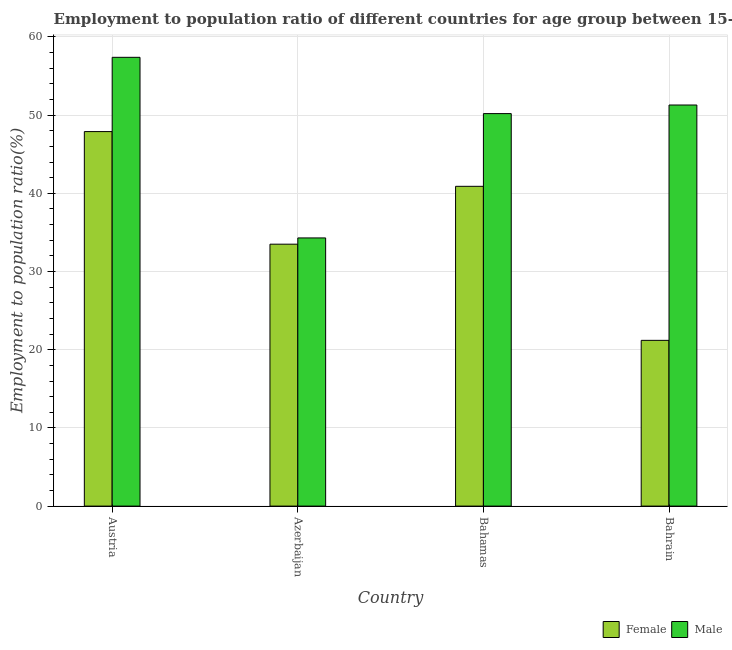How many different coloured bars are there?
Your answer should be compact. 2. How many groups of bars are there?
Offer a very short reply. 4. Are the number of bars per tick equal to the number of legend labels?
Give a very brief answer. Yes. How many bars are there on the 4th tick from the left?
Your response must be concise. 2. What is the label of the 4th group of bars from the left?
Keep it short and to the point. Bahrain. What is the employment to population ratio(female) in Azerbaijan?
Your answer should be compact. 33.5. Across all countries, what is the maximum employment to population ratio(male)?
Offer a terse response. 57.4. Across all countries, what is the minimum employment to population ratio(male)?
Provide a succinct answer. 34.3. In which country was the employment to population ratio(female) minimum?
Provide a short and direct response. Bahrain. What is the total employment to population ratio(male) in the graph?
Your response must be concise. 193.2. What is the difference between the employment to population ratio(male) in Bahamas and that in Bahrain?
Provide a short and direct response. -1.1. What is the difference between the employment to population ratio(male) in Bahamas and the employment to population ratio(female) in Austria?
Provide a succinct answer. 2.3. What is the average employment to population ratio(female) per country?
Ensure brevity in your answer.  35.88. What is the difference between the employment to population ratio(male) and employment to population ratio(female) in Bahamas?
Offer a terse response. 9.3. What is the ratio of the employment to population ratio(male) in Bahamas to that in Bahrain?
Keep it short and to the point. 0.98. Is the employment to population ratio(male) in Austria less than that in Bahrain?
Give a very brief answer. No. Is the difference between the employment to population ratio(female) in Azerbaijan and Bahamas greater than the difference between the employment to population ratio(male) in Azerbaijan and Bahamas?
Keep it short and to the point. Yes. What is the difference between the highest and the second highest employment to population ratio(male)?
Ensure brevity in your answer.  6.1. What is the difference between the highest and the lowest employment to population ratio(female)?
Your answer should be very brief. 26.7. In how many countries, is the employment to population ratio(female) greater than the average employment to population ratio(female) taken over all countries?
Ensure brevity in your answer.  2. Is the sum of the employment to population ratio(female) in Austria and Bahrain greater than the maximum employment to population ratio(male) across all countries?
Your answer should be very brief. Yes. What does the 2nd bar from the left in Bahrain represents?
Your answer should be very brief. Male. What does the 1st bar from the right in Austria represents?
Offer a terse response. Male. What is the difference between two consecutive major ticks on the Y-axis?
Offer a terse response. 10. Are the values on the major ticks of Y-axis written in scientific E-notation?
Offer a terse response. No. Does the graph contain any zero values?
Your response must be concise. No. Where does the legend appear in the graph?
Ensure brevity in your answer.  Bottom right. How many legend labels are there?
Offer a terse response. 2. How are the legend labels stacked?
Your answer should be very brief. Horizontal. What is the title of the graph?
Your answer should be compact. Employment to population ratio of different countries for age group between 15-24 years. What is the label or title of the X-axis?
Your answer should be compact. Country. What is the Employment to population ratio(%) of Female in Austria?
Your answer should be compact. 47.9. What is the Employment to population ratio(%) of Male in Austria?
Offer a terse response. 57.4. What is the Employment to population ratio(%) of Female in Azerbaijan?
Your response must be concise. 33.5. What is the Employment to population ratio(%) of Male in Azerbaijan?
Offer a very short reply. 34.3. What is the Employment to population ratio(%) in Female in Bahamas?
Provide a short and direct response. 40.9. What is the Employment to population ratio(%) of Male in Bahamas?
Ensure brevity in your answer.  50.2. What is the Employment to population ratio(%) in Female in Bahrain?
Offer a very short reply. 21.2. What is the Employment to population ratio(%) in Male in Bahrain?
Give a very brief answer. 51.3. Across all countries, what is the maximum Employment to population ratio(%) of Female?
Offer a terse response. 47.9. Across all countries, what is the maximum Employment to population ratio(%) in Male?
Provide a succinct answer. 57.4. Across all countries, what is the minimum Employment to population ratio(%) in Female?
Make the answer very short. 21.2. Across all countries, what is the minimum Employment to population ratio(%) of Male?
Offer a terse response. 34.3. What is the total Employment to population ratio(%) in Female in the graph?
Offer a terse response. 143.5. What is the total Employment to population ratio(%) of Male in the graph?
Your response must be concise. 193.2. What is the difference between the Employment to population ratio(%) in Female in Austria and that in Azerbaijan?
Your response must be concise. 14.4. What is the difference between the Employment to population ratio(%) in Male in Austria and that in Azerbaijan?
Your response must be concise. 23.1. What is the difference between the Employment to population ratio(%) of Female in Austria and that in Bahamas?
Your response must be concise. 7. What is the difference between the Employment to population ratio(%) in Male in Austria and that in Bahamas?
Your answer should be compact. 7.2. What is the difference between the Employment to population ratio(%) of Female in Austria and that in Bahrain?
Offer a terse response. 26.7. What is the difference between the Employment to population ratio(%) in Male in Austria and that in Bahrain?
Offer a terse response. 6.1. What is the difference between the Employment to population ratio(%) in Female in Azerbaijan and that in Bahamas?
Give a very brief answer. -7.4. What is the difference between the Employment to population ratio(%) of Male in Azerbaijan and that in Bahamas?
Provide a succinct answer. -15.9. What is the difference between the Employment to population ratio(%) in Male in Azerbaijan and that in Bahrain?
Offer a very short reply. -17. What is the difference between the Employment to population ratio(%) of Female in Austria and the Employment to population ratio(%) of Male in Bahamas?
Your answer should be compact. -2.3. What is the difference between the Employment to population ratio(%) of Female in Azerbaijan and the Employment to population ratio(%) of Male in Bahamas?
Provide a succinct answer. -16.7. What is the difference between the Employment to population ratio(%) of Female in Azerbaijan and the Employment to population ratio(%) of Male in Bahrain?
Provide a short and direct response. -17.8. What is the average Employment to population ratio(%) in Female per country?
Give a very brief answer. 35.88. What is the average Employment to population ratio(%) of Male per country?
Keep it short and to the point. 48.3. What is the difference between the Employment to population ratio(%) of Female and Employment to population ratio(%) of Male in Austria?
Make the answer very short. -9.5. What is the difference between the Employment to population ratio(%) in Female and Employment to population ratio(%) in Male in Bahrain?
Give a very brief answer. -30.1. What is the ratio of the Employment to population ratio(%) in Female in Austria to that in Azerbaijan?
Provide a short and direct response. 1.43. What is the ratio of the Employment to population ratio(%) of Male in Austria to that in Azerbaijan?
Offer a very short reply. 1.67. What is the ratio of the Employment to population ratio(%) of Female in Austria to that in Bahamas?
Your answer should be compact. 1.17. What is the ratio of the Employment to population ratio(%) in Male in Austria to that in Bahamas?
Your response must be concise. 1.14. What is the ratio of the Employment to population ratio(%) in Female in Austria to that in Bahrain?
Give a very brief answer. 2.26. What is the ratio of the Employment to population ratio(%) in Male in Austria to that in Bahrain?
Keep it short and to the point. 1.12. What is the ratio of the Employment to population ratio(%) of Female in Azerbaijan to that in Bahamas?
Make the answer very short. 0.82. What is the ratio of the Employment to population ratio(%) in Male in Azerbaijan to that in Bahamas?
Provide a succinct answer. 0.68. What is the ratio of the Employment to population ratio(%) in Female in Azerbaijan to that in Bahrain?
Offer a very short reply. 1.58. What is the ratio of the Employment to population ratio(%) of Male in Azerbaijan to that in Bahrain?
Your answer should be compact. 0.67. What is the ratio of the Employment to population ratio(%) of Female in Bahamas to that in Bahrain?
Offer a terse response. 1.93. What is the ratio of the Employment to population ratio(%) in Male in Bahamas to that in Bahrain?
Give a very brief answer. 0.98. What is the difference between the highest and the lowest Employment to population ratio(%) in Female?
Provide a short and direct response. 26.7. What is the difference between the highest and the lowest Employment to population ratio(%) in Male?
Provide a succinct answer. 23.1. 